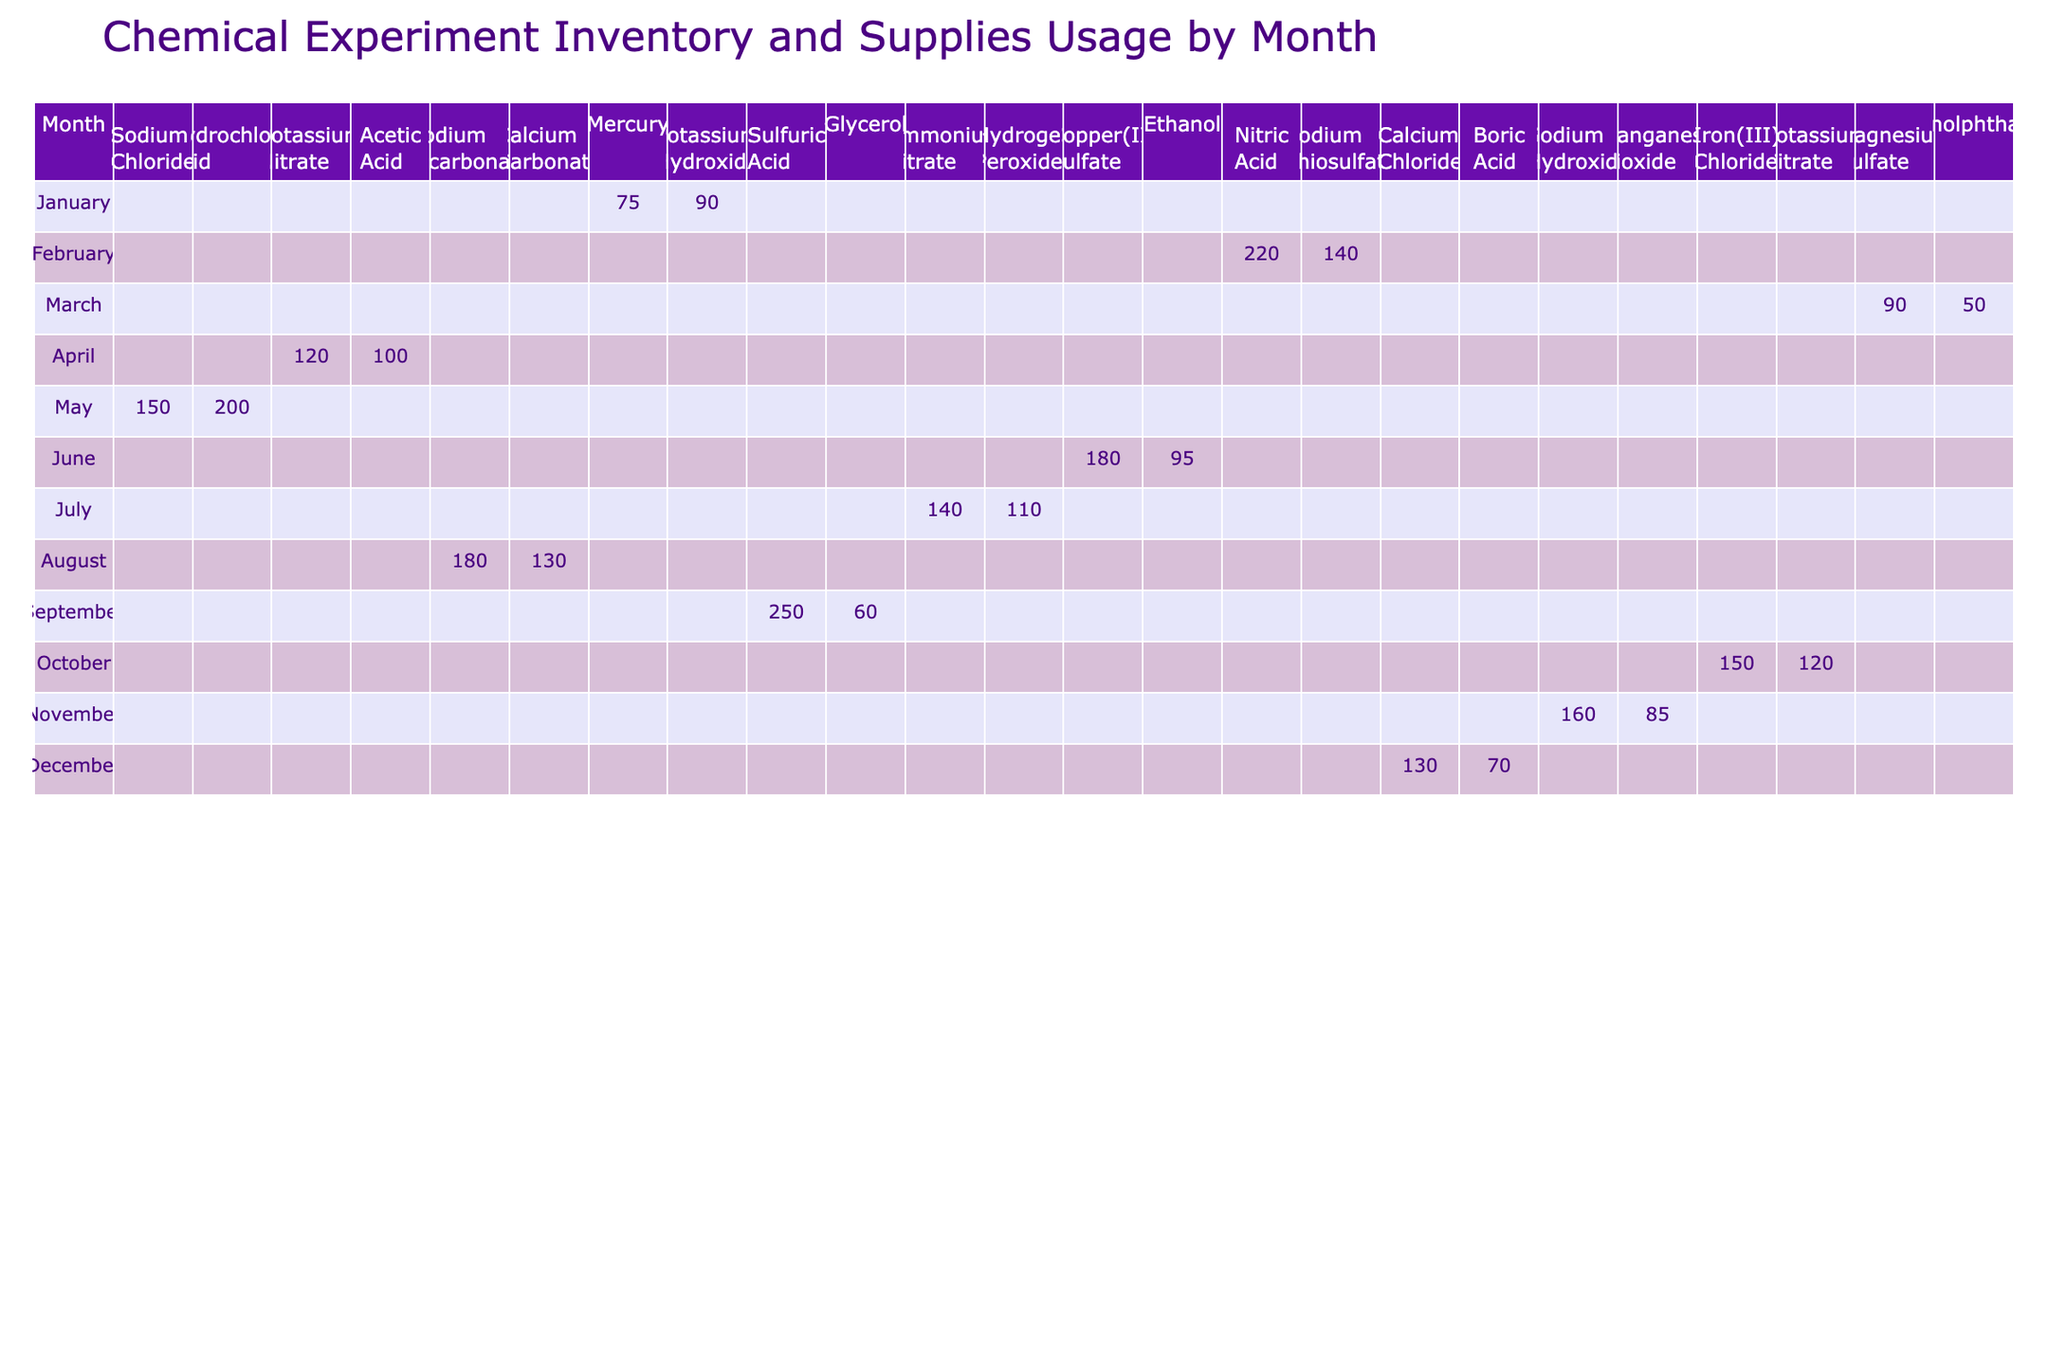What was the total quantity of Sodium Chloride used across all months? Looking at the table, I see that Sodium Chloride was used in January with 150 grams. There are no other entries for Sodium Chloride in the remaining months. Therefore, the total quantity used is simply 150 grams.
Answer: 150 grams Which month saw the highest usage of Nitric Acid? Referring to the table, I note that Nitric Acid was only recorded in August, with a quantity of 220 grams. Therefore, August is the month with the highest usage of Nitric Acid.
Answer: August How many experiments were conducted in March? In the table, the number of experiments for March is listed as 6 for Sodium Bicarbonate and 3 for Calcium Carbonate. To find the total, I add these two numbers: 6 + 3 = 9. Thus, a total of 9 experiments were conducted in March.
Answer: 9 Was Acetic Acid used in any month other than February? Checking the table, I see that Acetic Acid was recorded only in February with 100 grams used. There are no other entries for Acetic Acid in any of the other months. Therefore, the answer is no, Acetic Acid was not used in any other month.
Answer: No What is the average quantity of Chemical Compounds used in July? In July, the quantities used were 180 grams of Copper(II) Sulfate and 95 grams of Ethanol. First, I add these amounts: 180 + 95 = 275 grams. Then, to find the average, I divide by the number of compounds, which is 2: 275/2 = 137.5 grams. Therefore, the average quantity of Chemical Compounds used in July is 137.5 grams.
Answer: 137.5 grams In which month was Glycerol used, and how much was used? According to the table, Glycerol appears in May, where the quantity used is recorded as 60 grams. Therefore, Glycerol was used in May with the amount of 60 grams.
Answer: May, 60 grams What is the difference in the quantity used between the highest and the lowest Chemical Compound in October? In October, Sodium Hydroxide was used with 160 grams and Manganese Dioxide with 85 grams. To find the difference, I subtract the lower quantity from the higher one: 160 - 85 = 75 grams. Hence, the difference in quantity used is 75 grams.
Answer: 75 grams Was there any month where both Boric Acid and Calcium Chloride were used? Looking at the table, Boric Acid was recorded in September and Calcium Chloride was also used in September. Since both chemical compounds share the same month, I can confidently say that the answer is yes.
Answer: Yes How many total grams of Chemical Compounds were used in December? For December, I see magnesium sulfate used 90 grams and phenolphthalein used 50 grams. To find the total, I simply add these two amounts: 90 + 50 = 140 grams. Thus, the total quantity of Chemical Compounds used in December is 140 grams.
Answer: 140 grams 